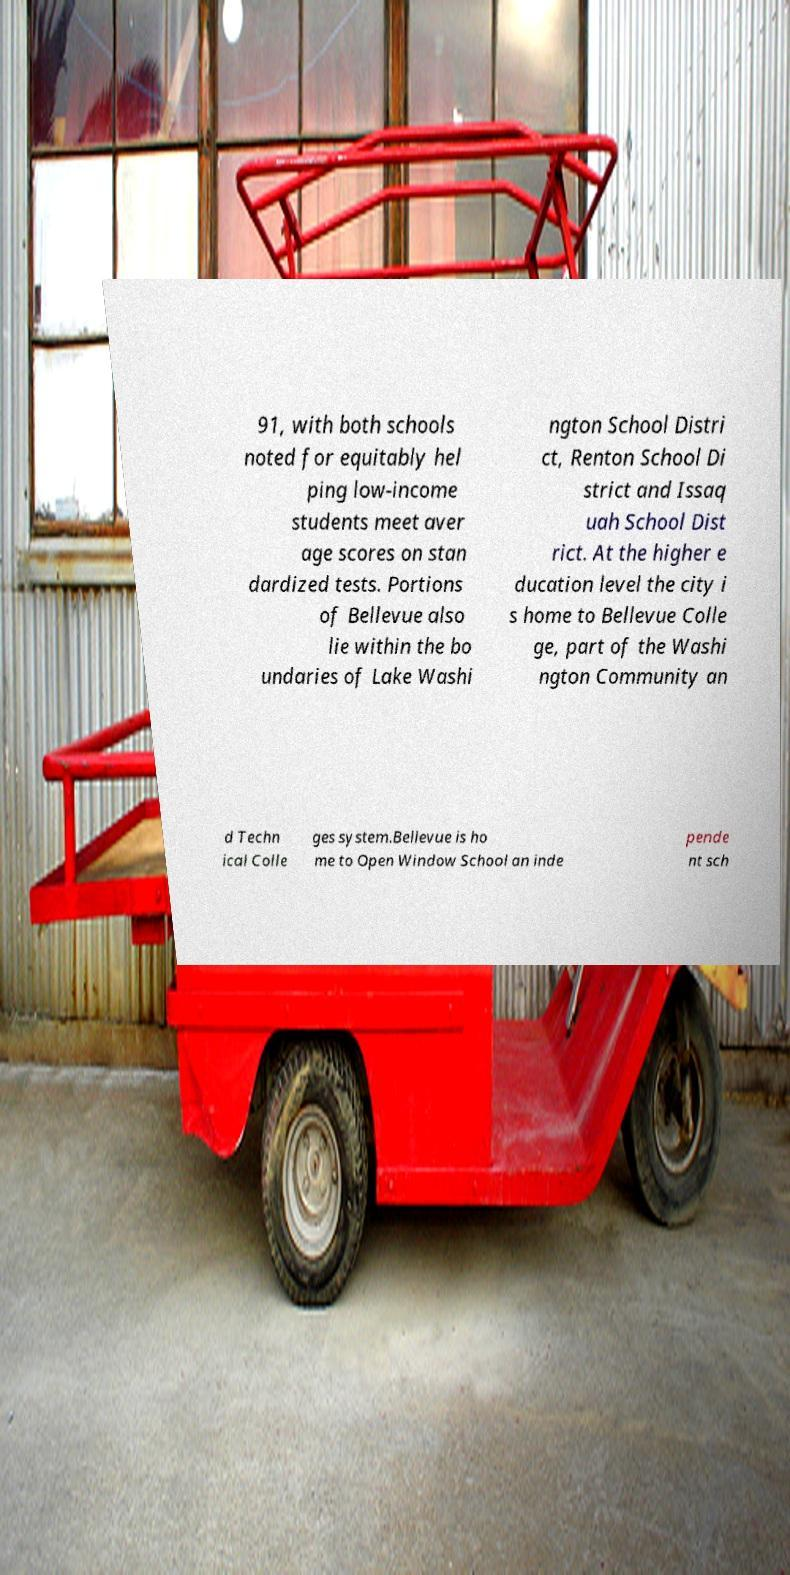Please identify and transcribe the text found in this image. 91, with both schools noted for equitably hel ping low-income students meet aver age scores on stan dardized tests. Portions of Bellevue also lie within the bo undaries of Lake Washi ngton School Distri ct, Renton School Di strict and Issaq uah School Dist rict. At the higher e ducation level the city i s home to Bellevue Colle ge, part of the Washi ngton Community an d Techn ical Colle ges system.Bellevue is ho me to Open Window School an inde pende nt sch 